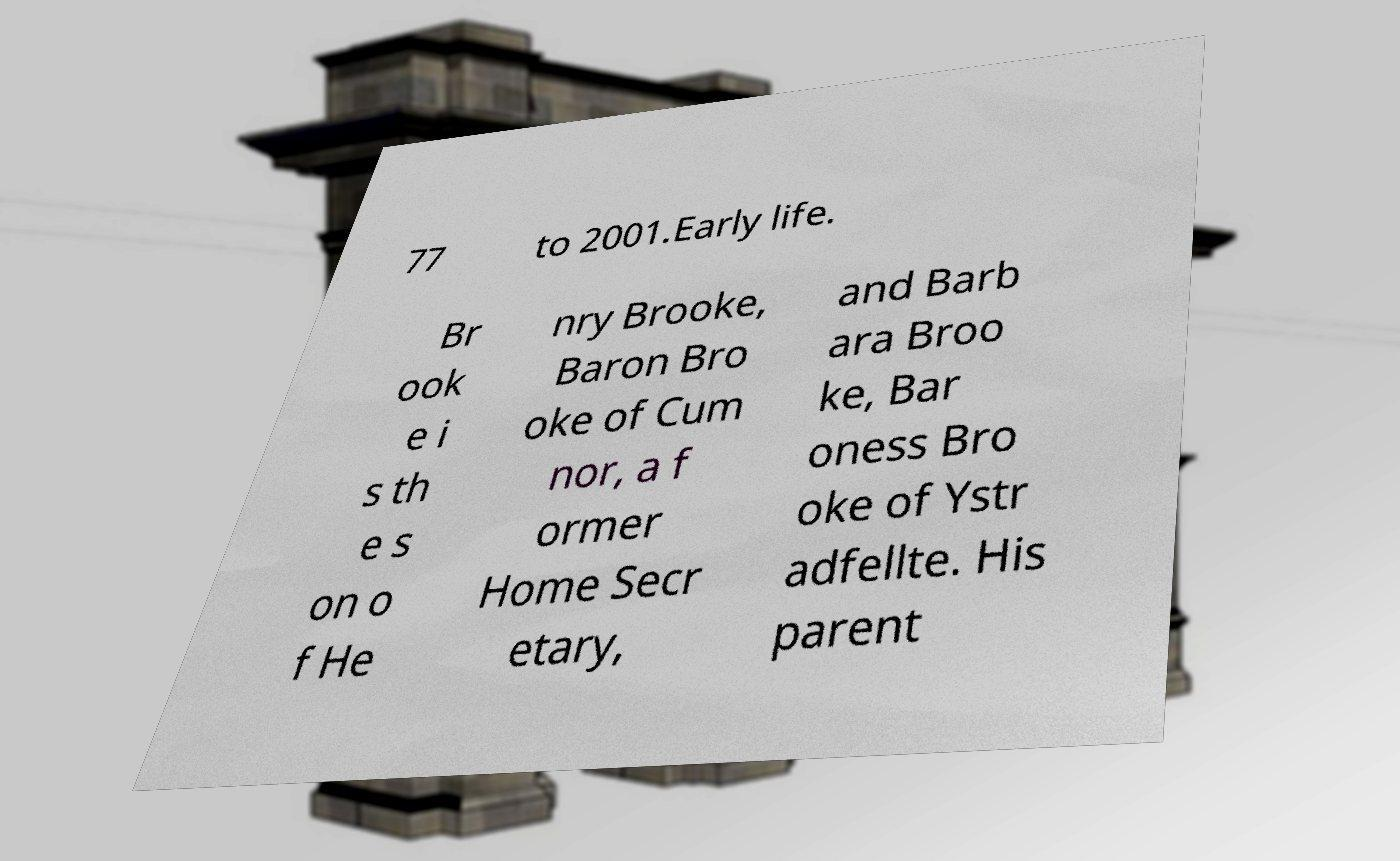Can you read and provide the text displayed in the image?This photo seems to have some interesting text. Can you extract and type it out for me? 77 to 2001.Early life. Br ook e i s th e s on o f He nry Brooke, Baron Bro oke of Cum nor, a f ormer Home Secr etary, and Barb ara Broo ke, Bar oness Bro oke of Ystr adfellte. His parent 